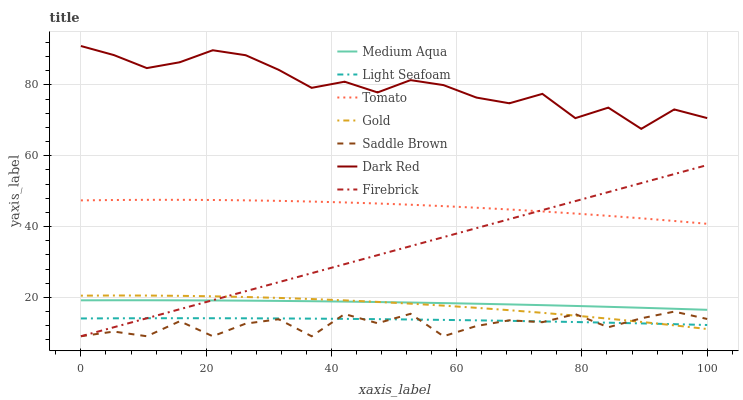Does Saddle Brown have the minimum area under the curve?
Answer yes or no. Yes. Does Dark Red have the maximum area under the curve?
Answer yes or no. Yes. Does Gold have the minimum area under the curve?
Answer yes or no. No. Does Gold have the maximum area under the curve?
Answer yes or no. No. Is Firebrick the smoothest?
Answer yes or no. Yes. Is Saddle Brown the roughest?
Answer yes or no. Yes. Is Gold the smoothest?
Answer yes or no. No. Is Gold the roughest?
Answer yes or no. No. Does Firebrick have the lowest value?
Answer yes or no. Yes. Does Gold have the lowest value?
Answer yes or no. No. Does Dark Red have the highest value?
Answer yes or no. Yes. Does Gold have the highest value?
Answer yes or no. No. Is Gold less than Tomato?
Answer yes or no. Yes. Is Tomato greater than Saddle Brown?
Answer yes or no. Yes. Does Firebrick intersect Saddle Brown?
Answer yes or no. Yes. Is Firebrick less than Saddle Brown?
Answer yes or no. No. Is Firebrick greater than Saddle Brown?
Answer yes or no. No. Does Gold intersect Tomato?
Answer yes or no. No. 